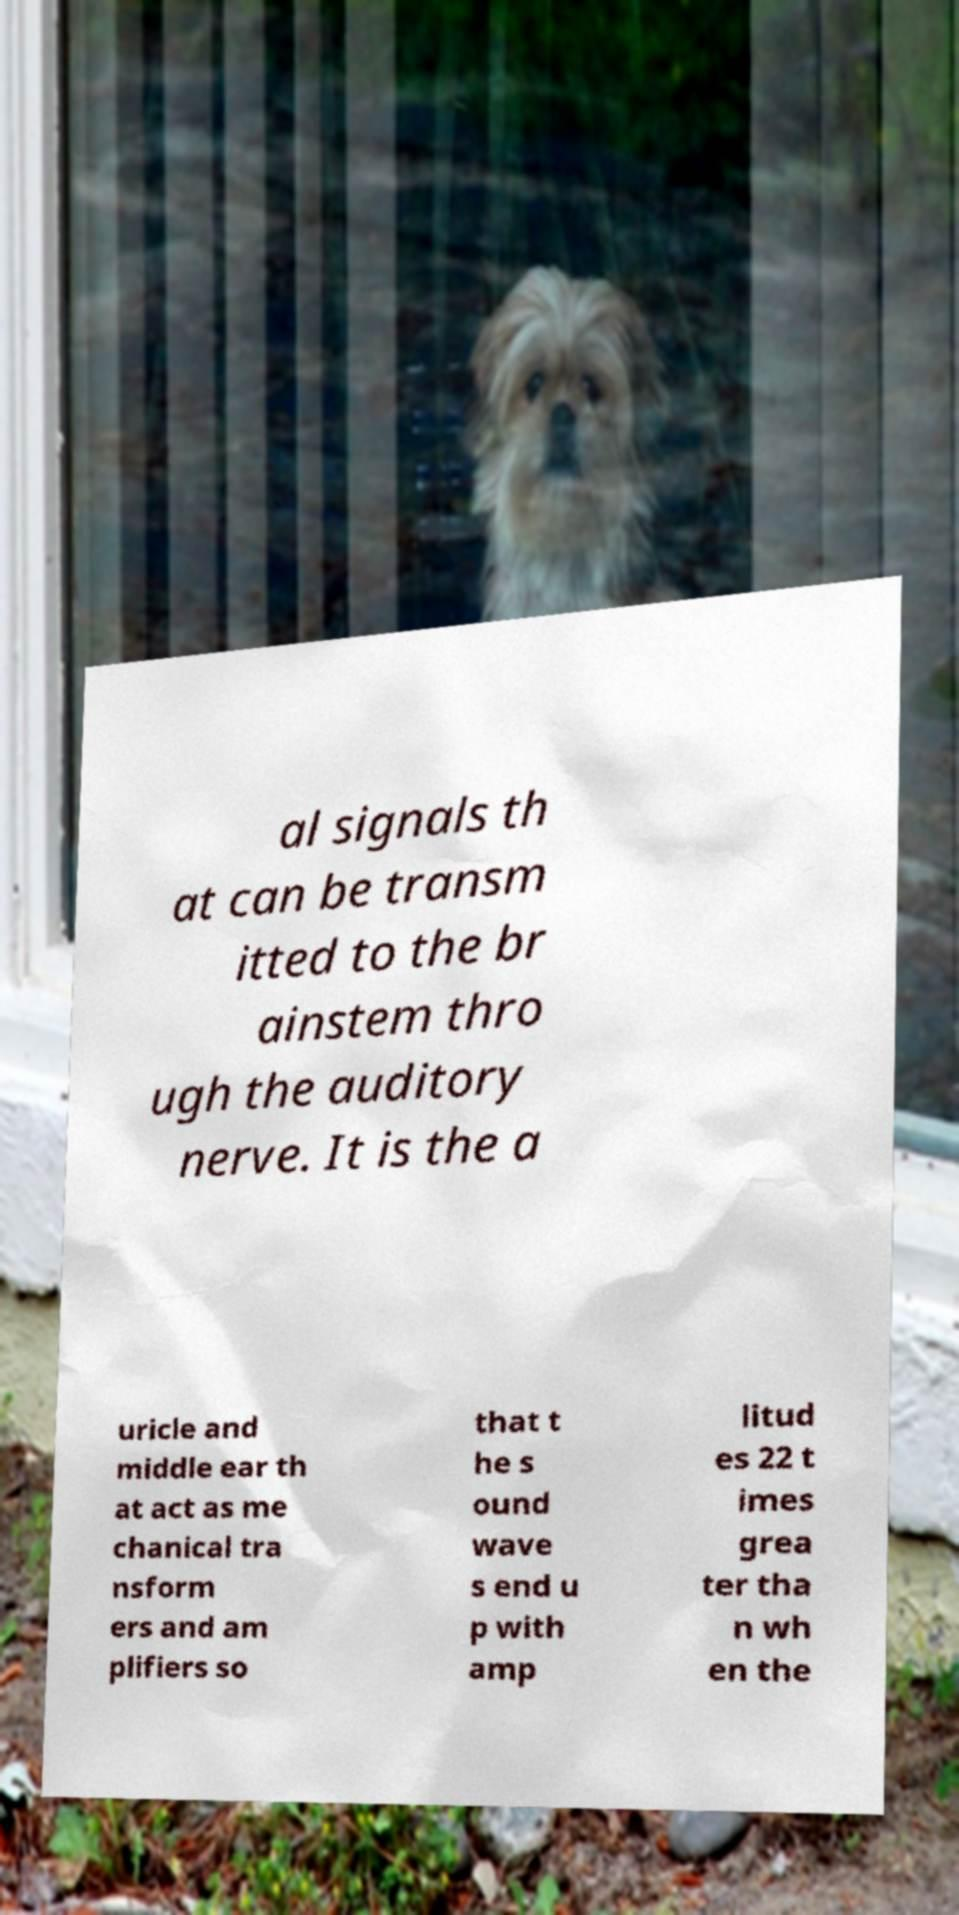Please read and relay the text visible in this image. What does it say? al signals th at can be transm itted to the br ainstem thro ugh the auditory nerve. It is the a uricle and middle ear th at act as me chanical tra nsform ers and am plifiers so that t he s ound wave s end u p with amp litud es 22 t imes grea ter tha n wh en the 